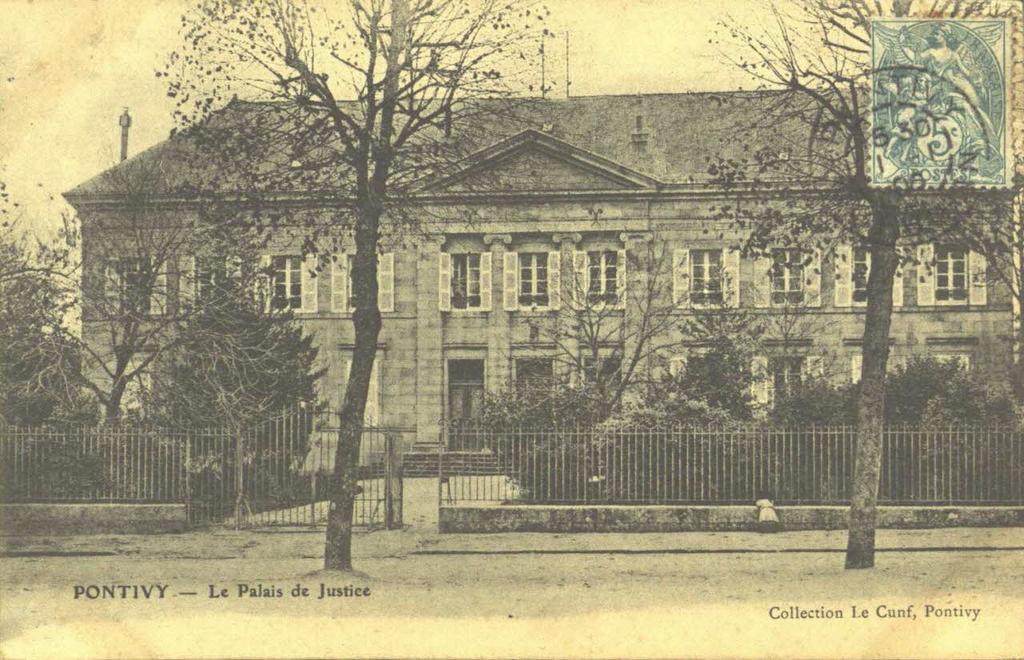How would you summarize this image in a sentence or two? This image consists of a poster with a text and a postage stamp on it. In this image there is a house with walls, windows, doors and roof and there are a few trees and plants. There is a railing. 